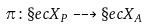Convert formula to latex. <formula><loc_0><loc_0><loc_500><loc_500>\pi \colon \S e c X _ { P } \dashrightarrow \S e c X _ { A }</formula> 